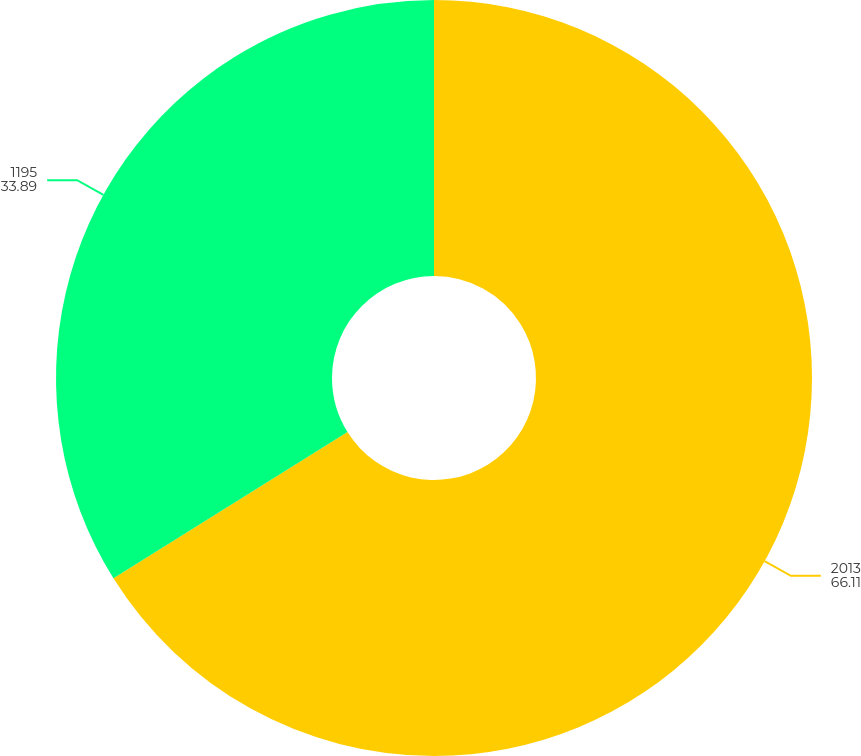Convert chart. <chart><loc_0><loc_0><loc_500><loc_500><pie_chart><fcel>2013<fcel>1195<nl><fcel>66.11%<fcel>33.89%<nl></chart> 